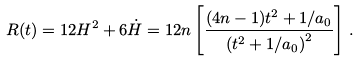Convert formula to latex. <formula><loc_0><loc_0><loc_500><loc_500>R ( t ) = 1 2 H ^ { 2 } + 6 \dot { H } = 1 2 n \left [ \frac { ( 4 n - 1 ) t ^ { 2 } + 1 / a _ { 0 } } { \left ( t ^ { 2 } + 1 / a _ { 0 } \right ) ^ { 2 } } \right ] \, .</formula> 